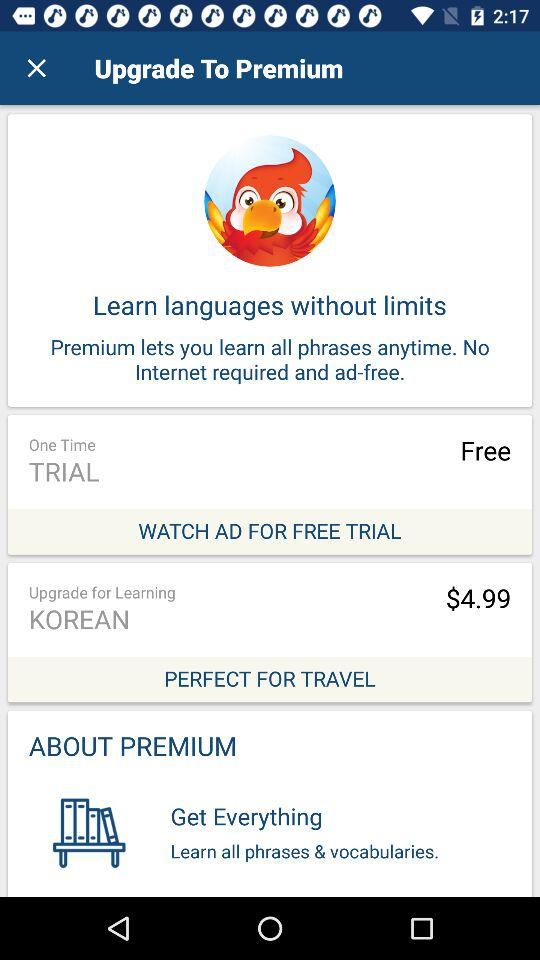How many dollars do we have to pay to learn Korean? You have to pay $4.99 to learn Korean. 